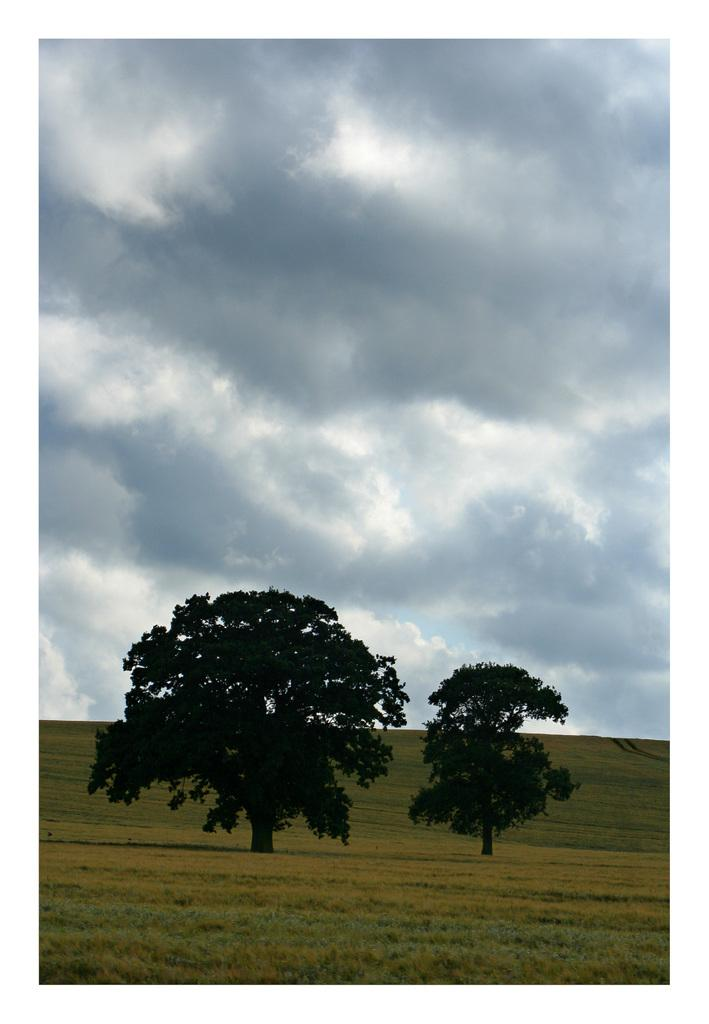What type of vegetation is present on the ground in the front of the image? There is grass on the ground in the front of the image. What can be seen in the center of the image? There are trees in the center of the image. What is the condition of the sky in the image? The sky is cloudy in the image. Are there any slaves visible in the image? There is no mention of slaves or any human figures in the image, so it cannot be determined if any are present. What type of wave can be seen in the image? There is no wave present in the image; it features grass, trees, and a cloudy sky. 